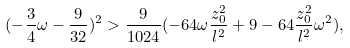<formula> <loc_0><loc_0><loc_500><loc_500>( - \frac { 3 } { 4 } \omega - \frac { 9 } { 3 2 } ) ^ { 2 } > \frac { 9 } { 1 0 2 4 } ( - 6 4 \omega \frac { z _ { 0 } ^ { 2 } } { l ^ { 2 } } + 9 - 6 4 \frac { z _ { 0 } ^ { 2 } } { l ^ { 2 } } \omega ^ { 2 } ) ,</formula> 